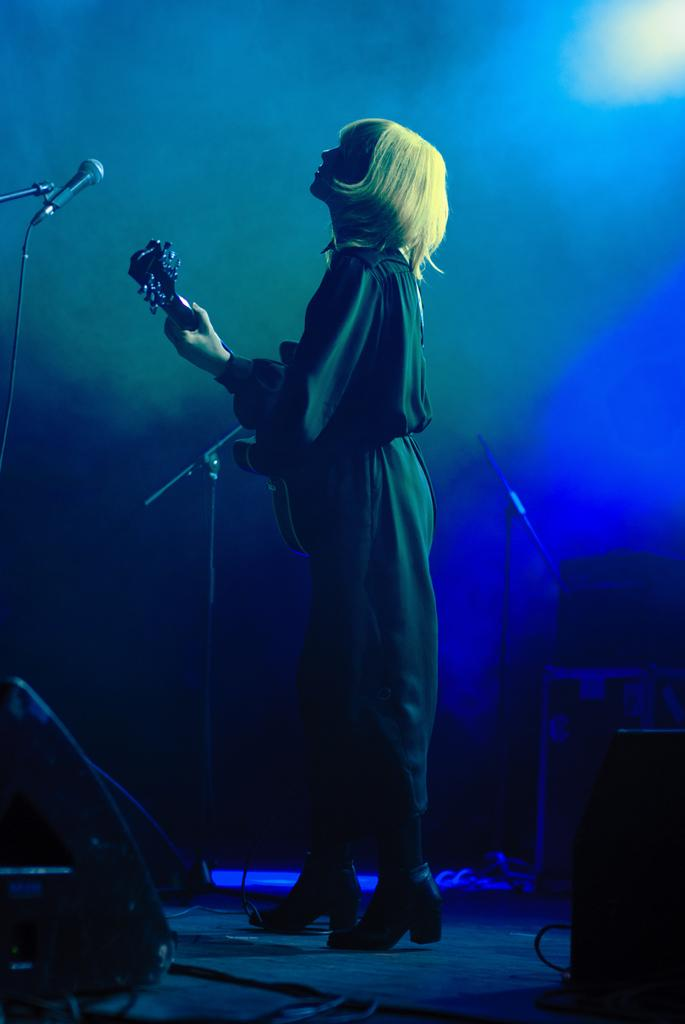Who is the main subject in the image? There is a woman in the image. What is the woman doing in the image? The woman is playing a guitar. What else can be seen in the image besides the woman? There are musical instruments around the woman. Can you describe the lighting in the image? There is a blue light focusing on the woman. What type of ticket does the woman have in her hand in the image? There is no ticket present in the image; the woman is playing a guitar and surrounded by musical instruments. 